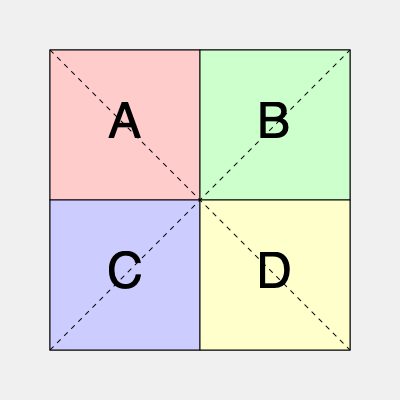Given the lab floor plan above with four equal-sized sections (A, B, C, and D), which arrangement of equipment would minimize travel time between workstations, assuming that the frequency of movement between sections follows this pattern: A↔B: 30%, A↔C: 25%, B↔D: 20%, C↔D: 15%, A↔D: 5%, B↔C: 5%? To determine the most efficient arrangement, we need to minimize the total distance traveled between workstations. Let's approach this step-by-step:

1. Analyze the movement frequencies:
   - Highest: A↔B (30%)
   - Second: A↔C (25%)
   - Third: B↔D (20%)
   - Fourth: C↔D (15%)
   - Lowest: A↔D and B↔C (5% each)

2. Consider the distances:
   - Adjacent sections (e.g., A↔B, A↔C) have the shortest distance.
   - Diagonal sections (e.g., A↔D, B↔C) have the longest distance.

3. Optimize the arrangement:
   - Place A and B adjacent to each other (30% movement).
   - Place A and C adjacent to each other (25% movement).
   - Place B and D adjacent to each other (20% movement).
   - Place C and D adjacent to each other (15% movement).
   - A↔D and B↔C will be diagonal, but they have the lowest frequency (5% each).

4. The optimal arrangement:
   A | B
   -----
   C | D

This arrangement satisfies all the high-frequency movements with adjacent placements and relegates the low-frequency movements to the diagonal positions.

5. Calculate efficiency:
   Adjacent movements: 30% + 25% + 20% + 15% = 90%
   Diagonal movements: 5% + 5% = 10%

This arrangement allows for 90% of the movements to occur between adjacent sections, minimizing overall travel time.
Answer: A | B
-----
C | D 